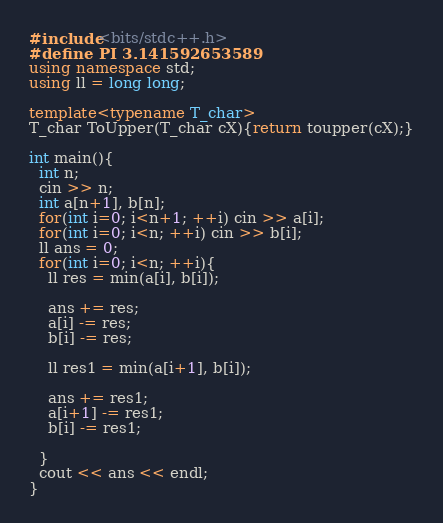<code> <loc_0><loc_0><loc_500><loc_500><_C++_>#include<bits/stdc++.h>
#define PI 3.141592653589
using namespace std;
using ll = long long;

template<typename T_char>
T_char ToUpper(T_char cX){return toupper(cX);}

int main(){
  int n;
  cin >> n;
  int a[n+1], b[n];
  for(int i=0; i<n+1; ++i) cin >> a[i];
  for(int i=0; i<n; ++i) cin >> b[i];
  ll ans = 0;
  for(int i=0; i<n; ++i){
    ll res = min(a[i], b[i]);

    ans += res;
    a[i] -= res;
    b[i] -= res;

    ll res1 = min(a[i+1], b[i]);

    ans += res1;
    a[i+1] -= res1;
    b[i] -= res1;

  }
  cout << ans << endl;
}</code> 